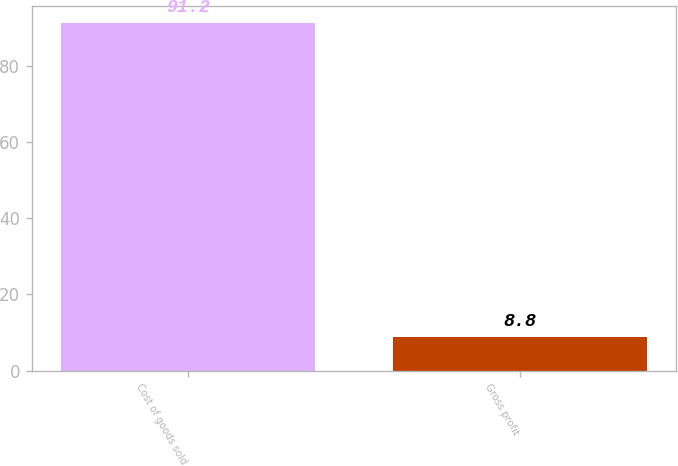<chart> <loc_0><loc_0><loc_500><loc_500><bar_chart><fcel>Cost of goods sold<fcel>Gross profit<nl><fcel>91.2<fcel>8.8<nl></chart> 